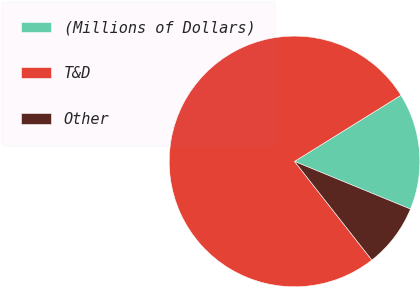Convert chart to OTSL. <chart><loc_0><loc_0><loc_500><loc_500><pie_chart><fcel>(Millions of Dollars)<fcel>T&D<fcel>Other<nl><fcel>15.06%<fcel>76.72%<fcel>8.21%<nl></chart> 